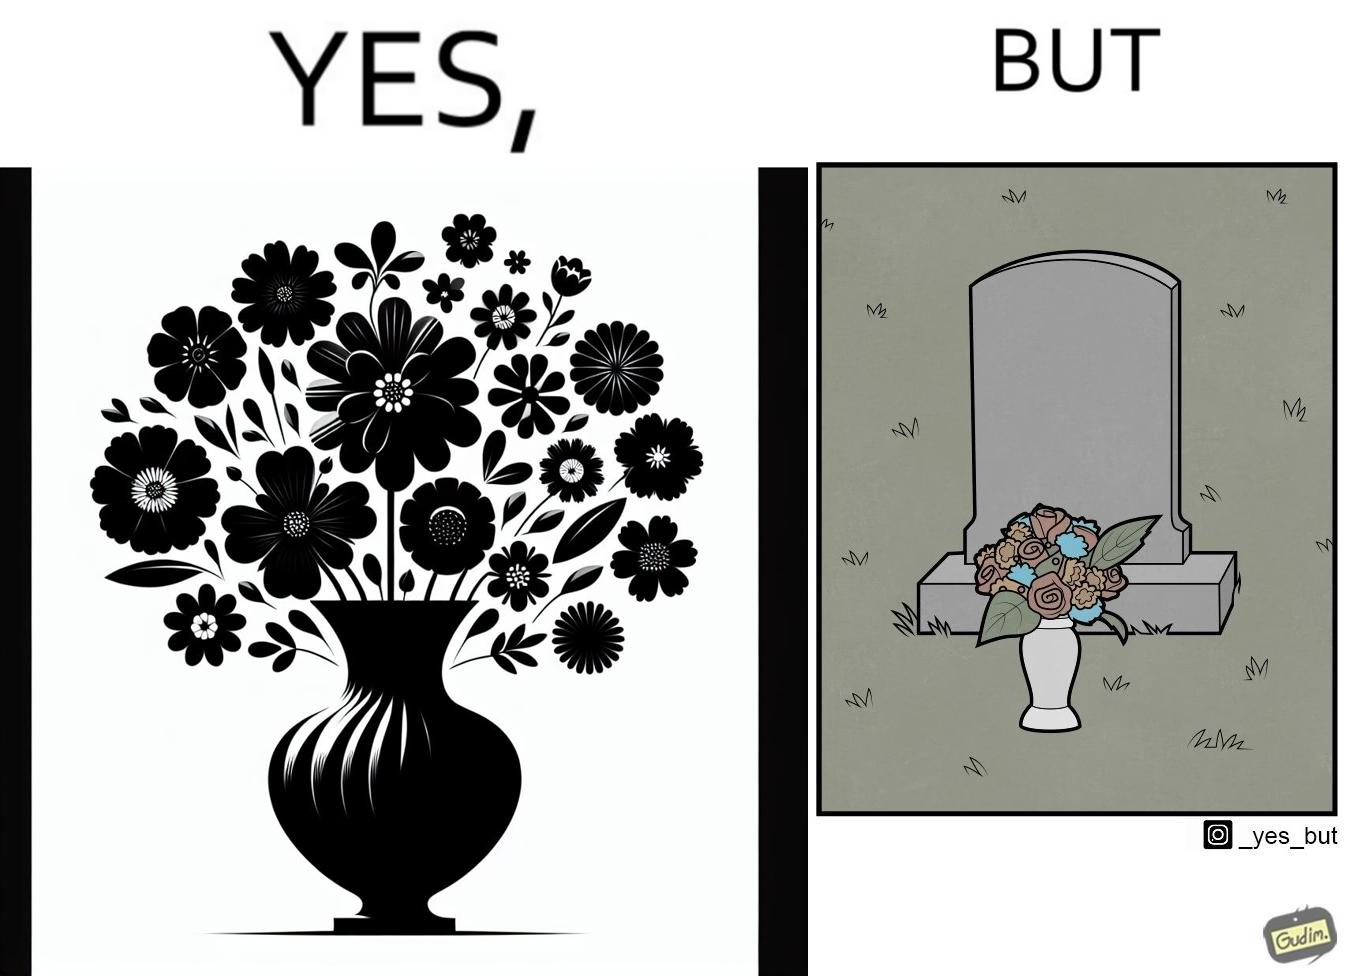What makes this image funny or satirical? The image is ironic, because in the first image a vase full of different beautiful flowers is seen which spreads a feeling of positivity, cheerfulness etc., whereas in the second image when the same vase is put in front of a grave stone it produces a feeling of sorrow 